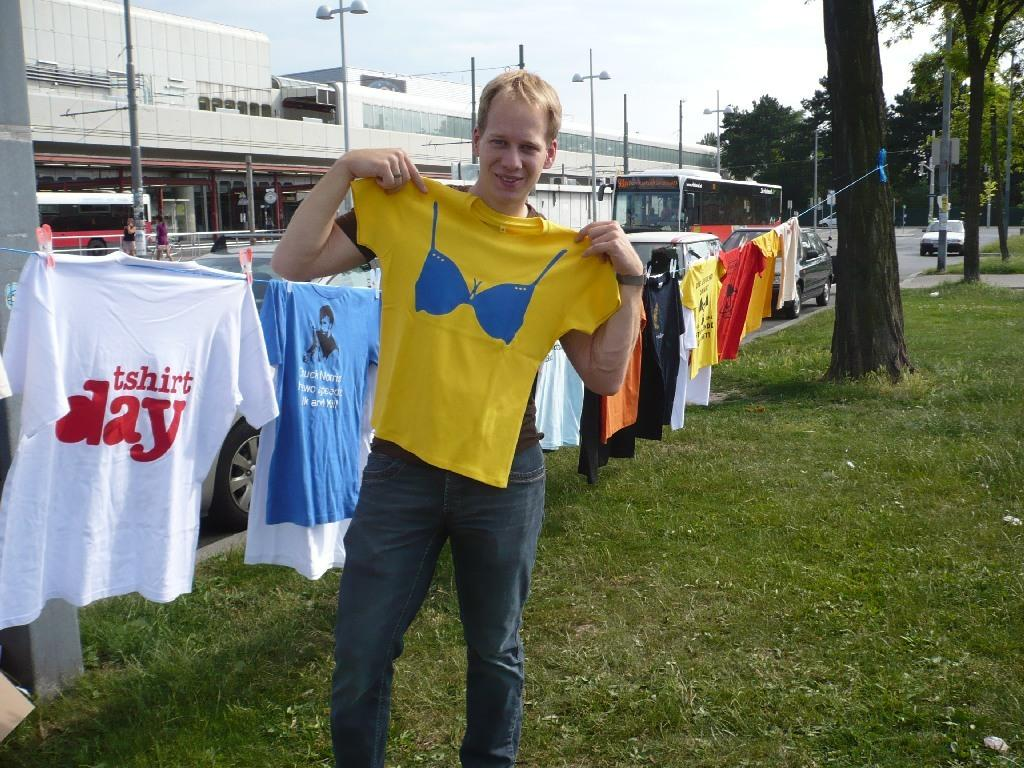<image>
Write a terse but informative summary of the picture. a boy holding up a tshirt with a clothes line full of shirts behind him for TSHIRT DAY 